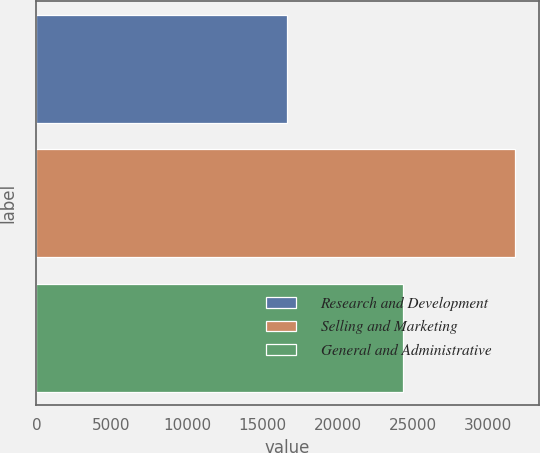Convert chart. <chart><loc_0><loc_0><loc_500><loc_500><bar_chart><fcel>Research and Development<fcel>Selling and Marketing<fcel>General and Administrative<nl><fcel>16659<fcel>31761<fcel>24363<nl></chart> 